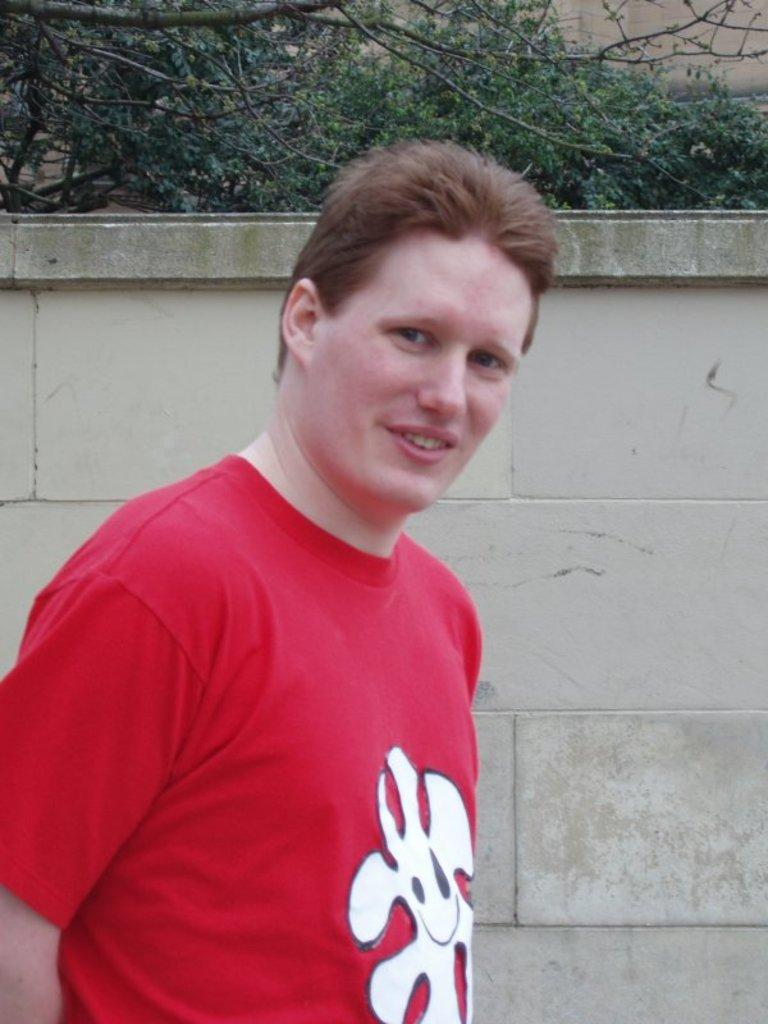What is the main subject of the image? The main subject of the image is a man standing. Where is the man standing in relation to the wall? The man is standing at a wall. What can be seen in the background of the image? There are trees and a wall visible in the background of the image. What verse can be heard being recited by the ghost in the image? There is no ghost or verse present in the image; it features a man standing at a wall. 